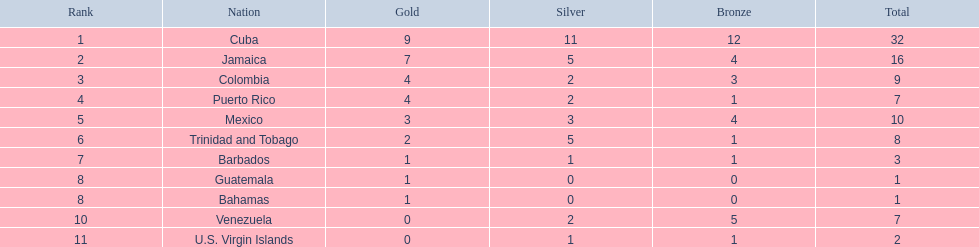What nation has won at least 4 gold medals? Cuba, Jamaica, Colombia, Puerto Rico. Of these countries who has won the least amount of bronze medals? Puerto Rico. 